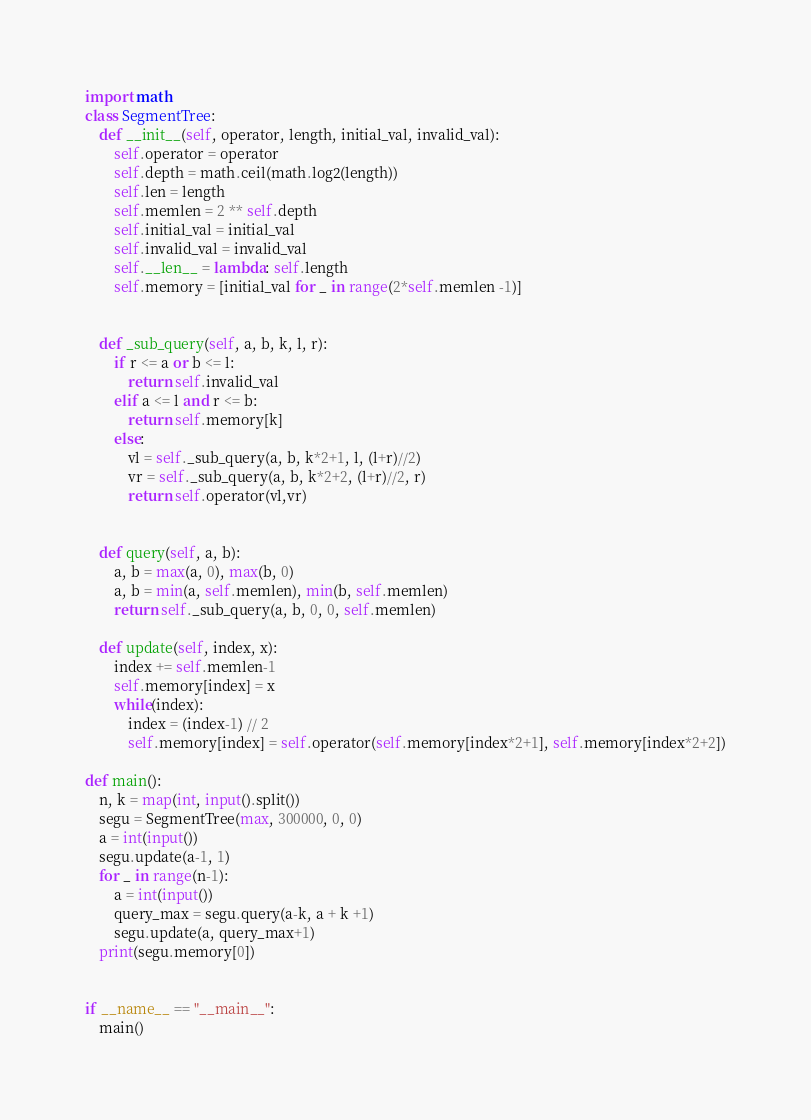<code> <loc_0><loc_0><loc_500><loc_500><_Python_>import math
class SegmentTree:
    def __init__(self, operator, length, initial_val, invalid_val):
        self.operator = operator
        self.depth = math.ceil(math.log2(length))
        self.len = length
        self.memlen = 2 ** self.depth
        self.initial_val = initial_val
        self.invalid_val = invalid_val
        self.__len__ = lambda: self.length
        self.memory = [initial_val for _ in range(2*self.memlen -1)]


    def _sub_query(self, a, b, k, l, r):
        if r <= a or b <= l:
            return self.invalid_val
        elif a <= l and r <= b:
            return self.memory[k]
        else:
            vl = self._sub_query(a, b, k*2+1, l, (l+r)//2)
            vr = self._sub_query(a, b, k*2+2, (l+r)//2, r)
            return self.operator(vl,vr)


    def query(self, a, b):
        a, b = max(a, 0), max(b, 0)
        a, b = min(a, self.memlen), min(b, self.memlen)
        return self._sub_query(a, b, 0, 0, self.memlen)

    def update(self, index, x):
        index += self.memlen-1
        self.memory[index] = x
        while(index):
            index = (index-1) // 2
            self.memory[index] = self.operator(self.memory[index*2+1], self.memory[index*2+2])

def main():
    n, k = map(int, input().split())
    segu = SegmentTree(max, 300000, 0, 0)
    a = int(input())
    segu.update(a-1, 1)
    for _ in range(n-1):
        a = int(input())
        query_max = segu.query(a-k, a + k +1)
        segu.update(a, query_max+1)
    print(segu.memory[0])


if __name__ == "__main__":
    main()
</code> 